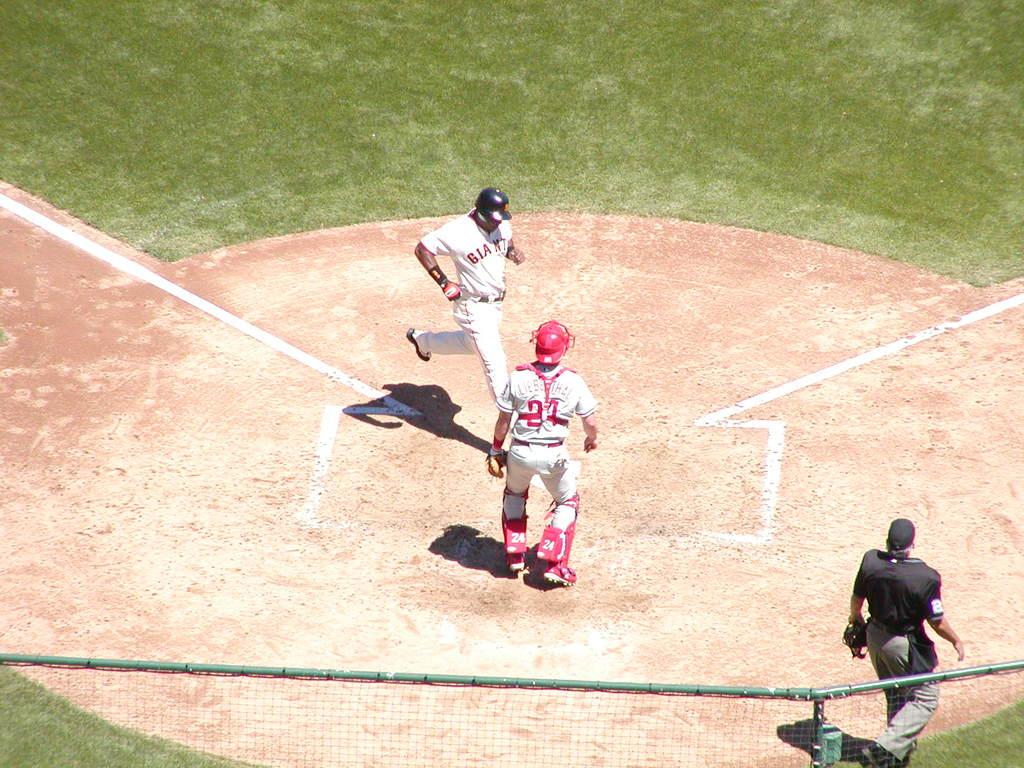<image>
Share a concise interpretation of the image provided. A person wearing a Giants jersey runs toward home plate. 